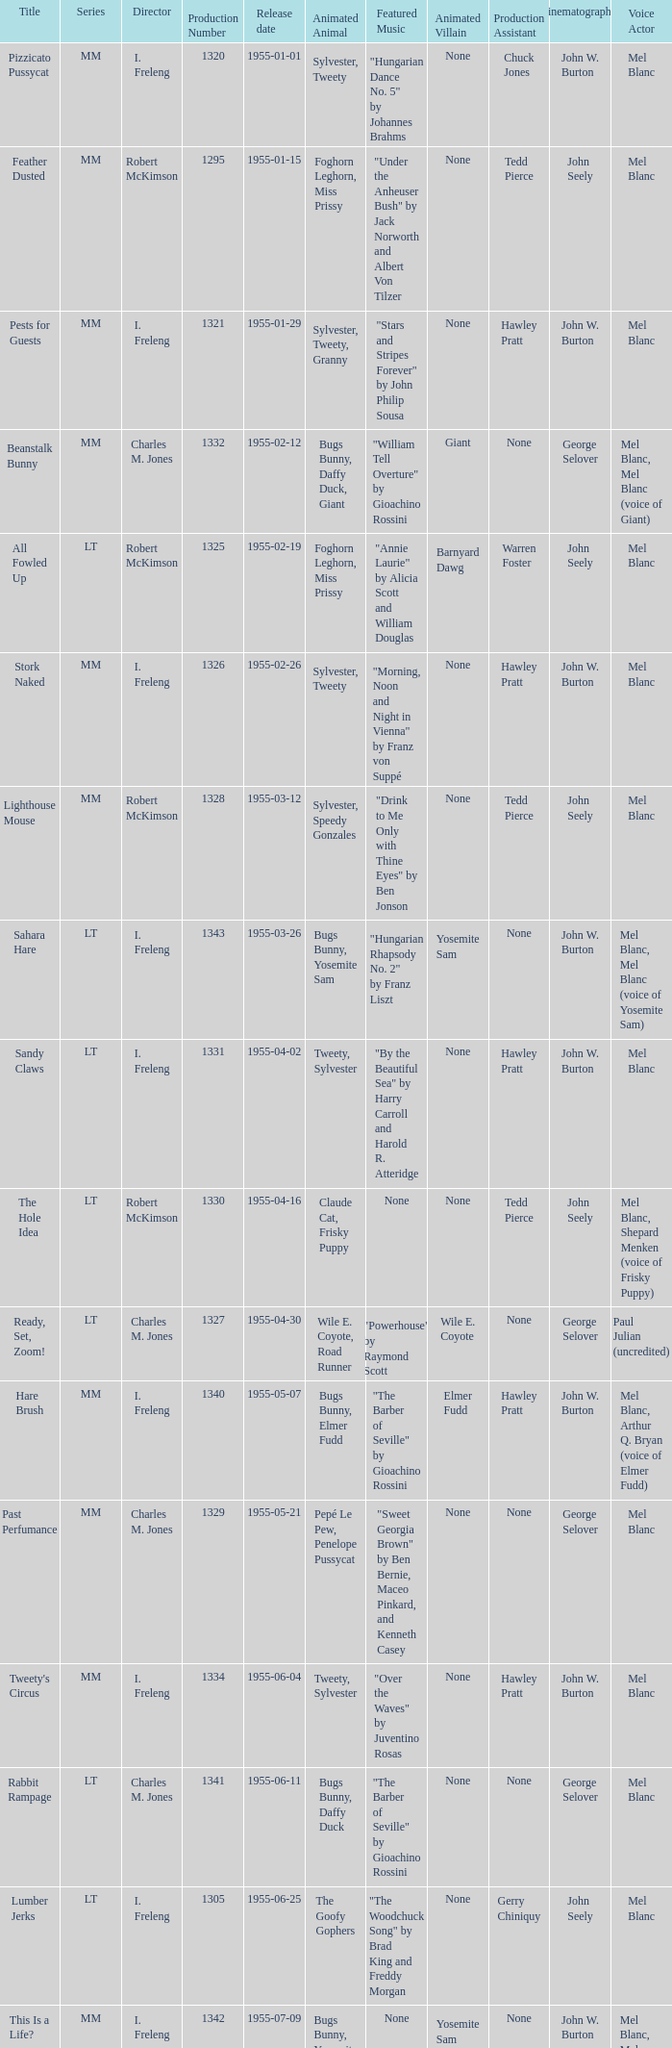What is the title with the production number greater than 1334 released on 1955-08-27? Hyde and Hare. 